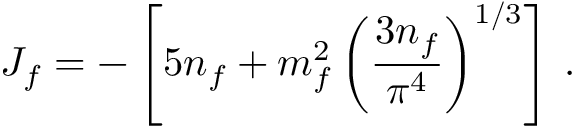<formula> <loc_0><loc_0><loc_500><loc_500>J _ { f } = - \left [ 5 n _ { f } + m _ { f } ^ { 2 } \left ( { \frac { 3 n _ { f } } { \pi ^ { 4 } } } \right ) ^ { 1 / 3 } \right ] \, .</formula> 